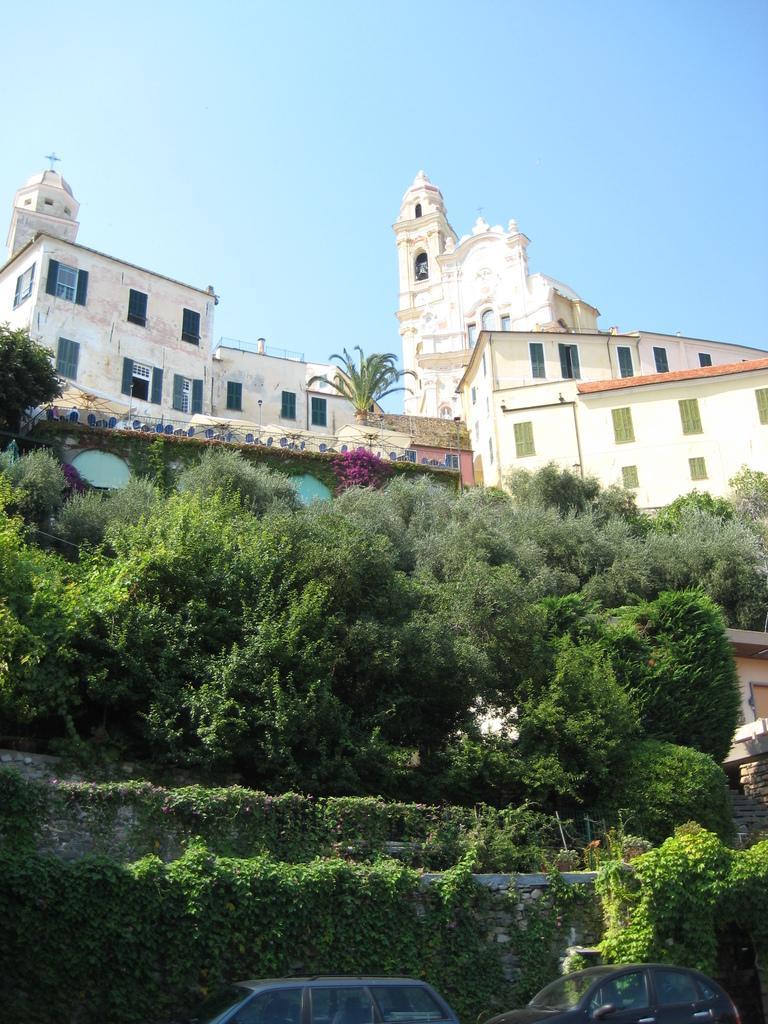Could you give a brief overview of what you see in this image? This is an outside view. At the bottom, I can see two cars and there is a wall. To the wall there are some creeper plants. In the middle of the image there are some trees. In the background, I can see the buildings. At the top of the image I can see the sky. 